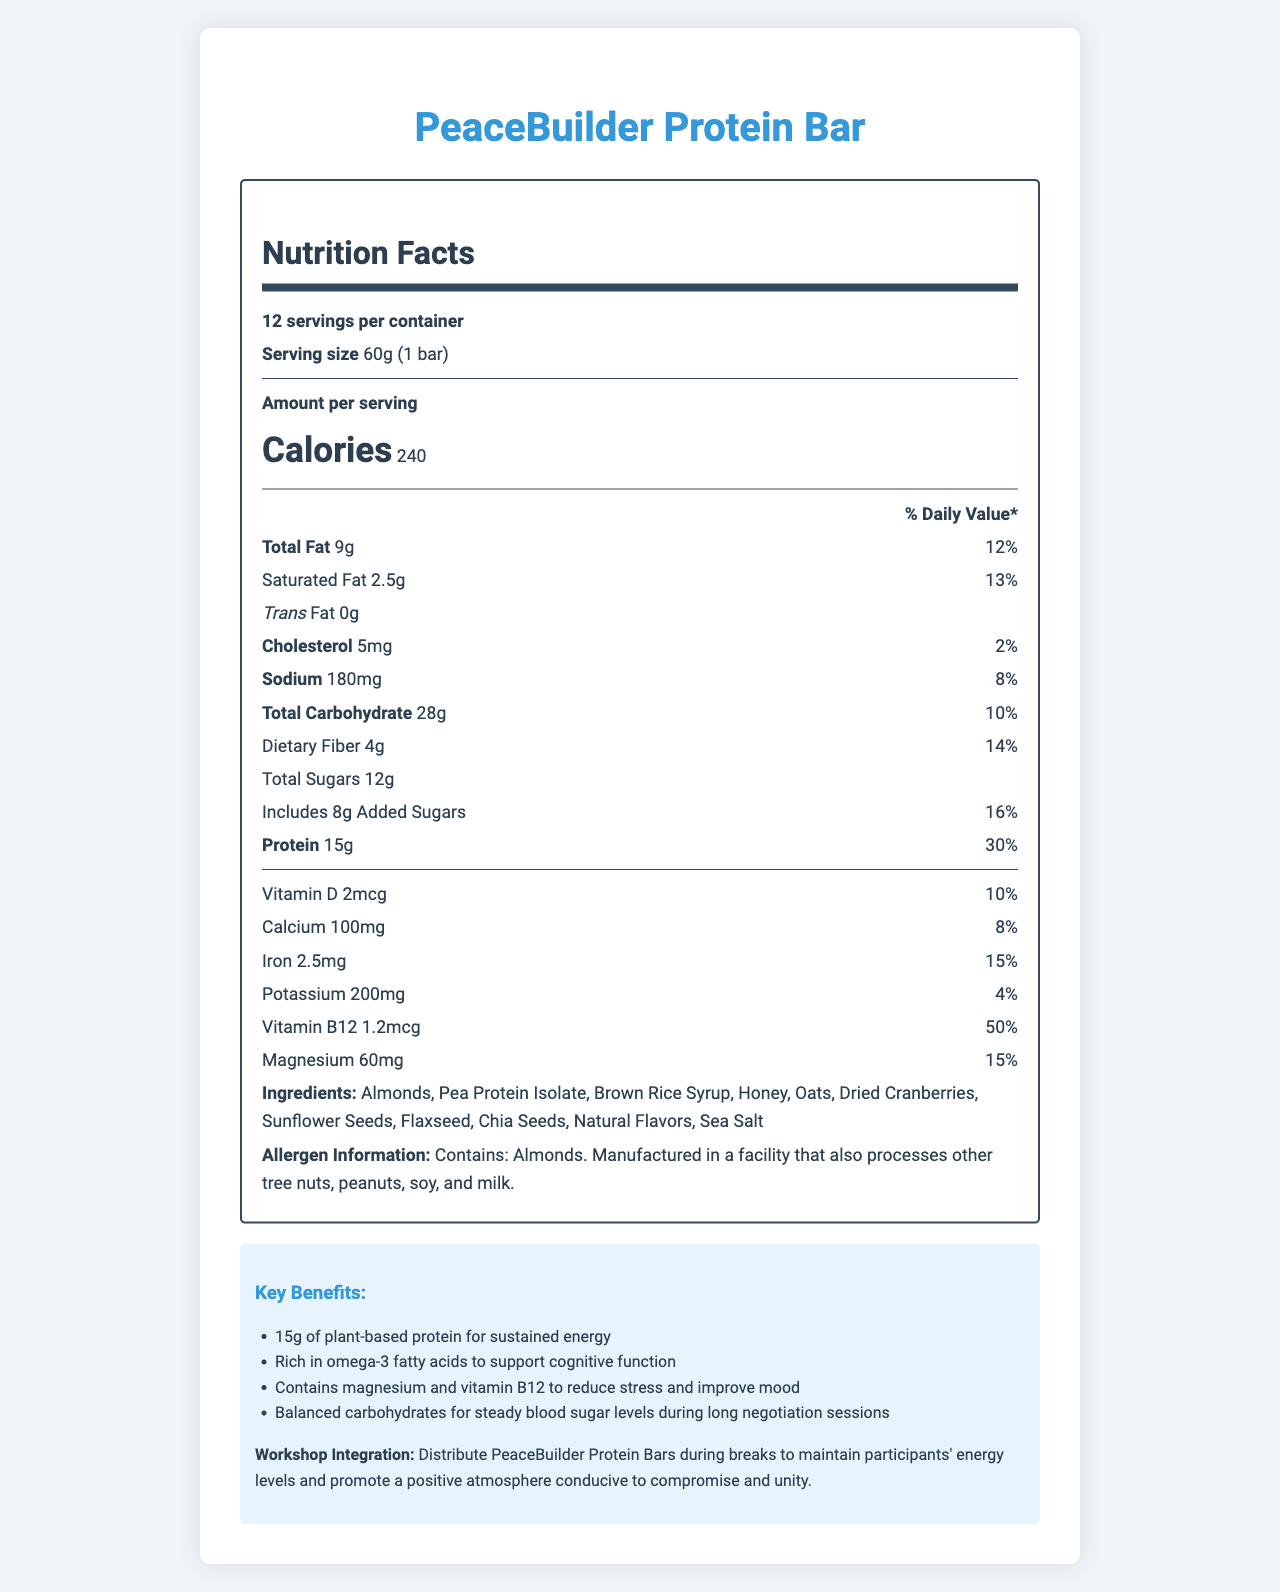who makes the PeaceBuilder Protein Bar? The document does not mention the manufacturer of the PeaceBuilder Protein Bar.
Answer: Cannot be determined What is the serving size of the PeaceBuilder Protein Bar? The document states that the serving size is "60g (1 bar)".
Answer: 60g (1 bar) How many servings are there per container? The document specifies that there are 12 servings per container.
Answer: 12 How many calories are there per serving? The document shows that there are 240 calories per serving.
Answer: 240 What percentage of the Daily Value is the saturated fat in the PeaceBuilder Protein Bar? The Nutrition Facts section lists the Daily Value for saturated fat as 13%.
Answer: 13% How much dietary fiber is in a single serving? According to the document, each serving contains 4g of dietary fiber.
Answer: 4g Does the PeaceBuilder Protein Bar contain any trans fat? The document states that the trans fat content is "0g".
Answer: No What ingredients come after "Honey" in the list? The ingredients listed after "Honey" are "Oats, Dried Cranberries, Sunflower Seeds, Flaxseed, Chia Seeds, Natural Flavors, and Sea Salt".
Answer: Oats, Dried Cranberries, Sunflower Seeds, Flaxseed, Chia Seeds, Natural Flavors, Sea Salt What are some key benefits of the PeaceBuilder Protein Bar? The document lists the key benefits in the "Key Benefits" section.
Answer: 15g of plant-based protein for sustained energy; Rich in omega-3 fatty acids to support cognitive function; Contains magnesium and vitamin B12 to reduce stress and improve mood; Balanced carbohydrates for steady blood sugar levels during long negotiation sessions What is the percentage of daily value for magnesium in a PeaceBuilder Protein Bar? The document provides that the Daily Value for magnesium is 15%.
Answer: 15% What is the main idea of the PeaceBuilder Protein Bar's marketing message? The document focuses on the nutritional benefits and how the bar supports energy and focus during conflict resolution workshops.
Answer: The PeaceBuilder Protein Bar is designed to provide sustained energy, mental clarity, and promote a positive atmosphere during conflict resolution workshops, leveraging its balanced mix of proteins, healthy fats, and complex carbohydrates. The PeaceBuilder Protein Bar contains how much added sugar per serving? The Nutrition Facts indicate that each serving includes 8g of added sugars.
Answer: 8g Is the PeaceBuilder Protein Bar suitable for individuals with nut allergies? The Allergen Information section notes that the bar contains almonds and is manufactured in a facility that processes other tree nuts, peanuts, soy, and milk.
Answer: No Which of the following nutrients has the highest percentage of daily value per serving? A. Calcium B. Iron C. Vitamin B12 The document lists Vitamin B12 with a Daily Value of 50%, which is higher than Calcium (8%) and Iron (15%).
Answer: C. Vitamin B12 What is the amount of potassium in one serving of the PeaceBuilder Protein Bar? A. 100mg B. 180mg C. 200mg The document mentions that one serving contains 200mg of potassium.
Answer: C. 200mg Is there any chocolate listed in the ingredients of the PeaceBuilder Protein Bar? The ingredients list does not mention chocolate.
Answer: No 